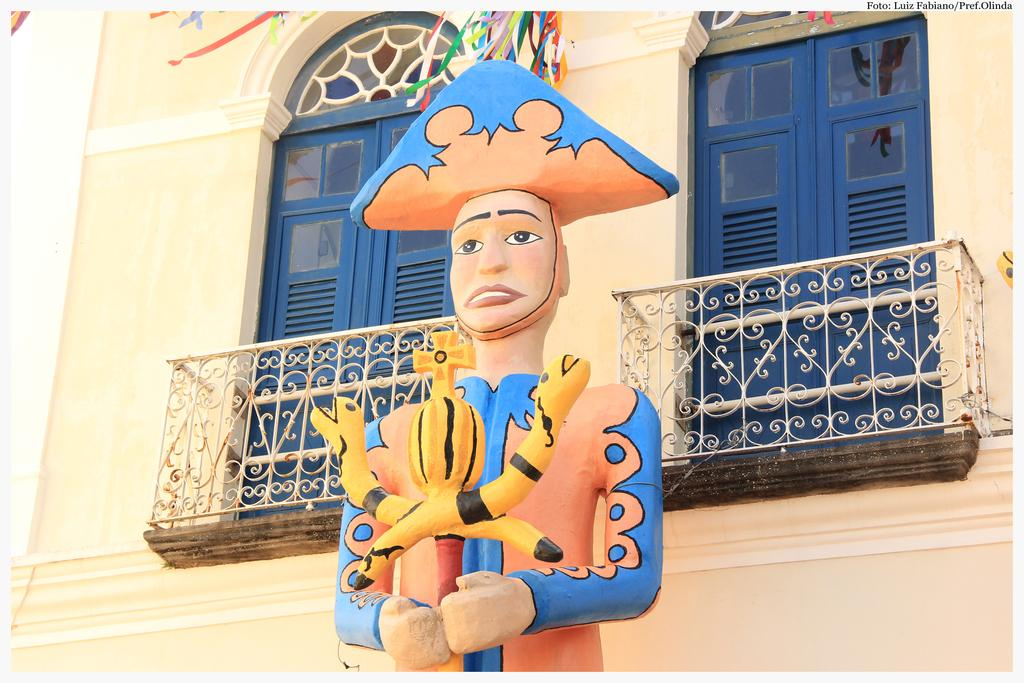How many doors are there to the building in the image? There are two doors to the building in the image. What can be found in front of the building? In front of the building, there is a sculpture. What type of flower is growing near the sculpture in the image? There is no flower present in the image; it features a sculpture in front of a building with two doors. How many laborers are working on the building in the image? There are no laborers present in the image; it only shows a building with two doors and a sculpture in front of it. 